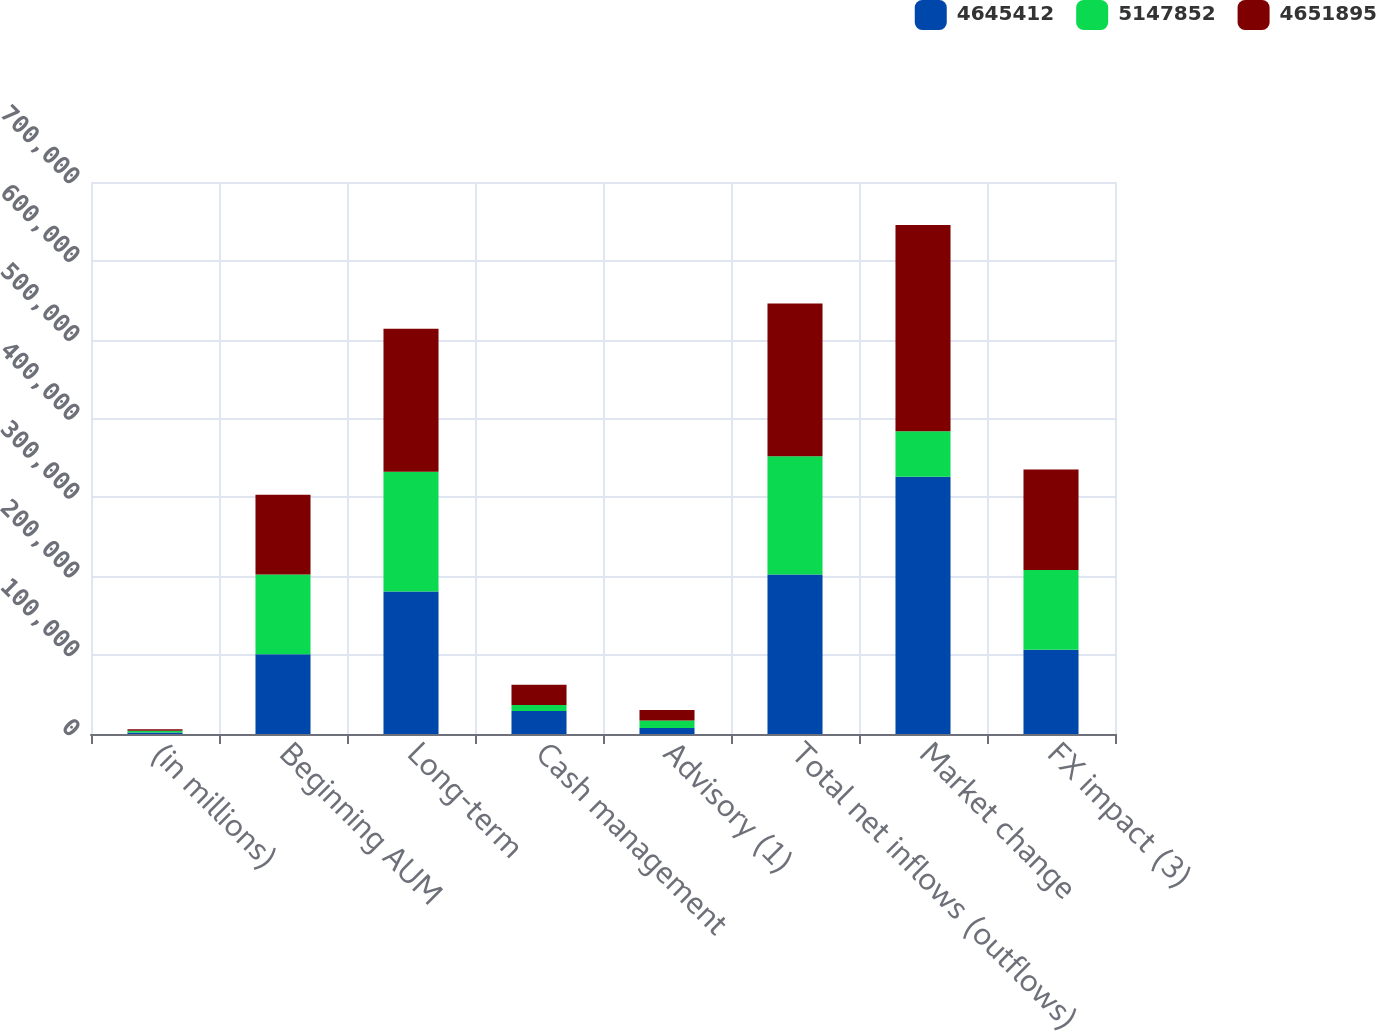Convert chart. <chart><loc_0><loc_0><loc_500><loc_500><stacked_bar_chart><ecel><fcel>(in millions)<fcel>Beginning AUM<fcel>Long-term<fcel>Cash management<fcel>Advisory (1)<fcel>Total net inflows (outflows)<fcel>Market change<fcel>FX impact (3)<nl><fcel>4.64541e+06<fcel>2016<fcel>101102<fcel>180564<fcel>29228<fcel>7601<fcel>202191<fcel>326364<fcel>106750<nl><fcel>5.14785e+06<fcel>2015<fcel>101102<fcel>152014<fcel>7510<fcel>9629<fcel>149895<fcel>57495<fcel>101102<nl><fcel>4.6519e+06<fcel>2014<fcel>101102<fcel>181253<fcel>25696<fcel>13173<fcel>193776<fcel>261682<fcel>127651<nl></chart> 